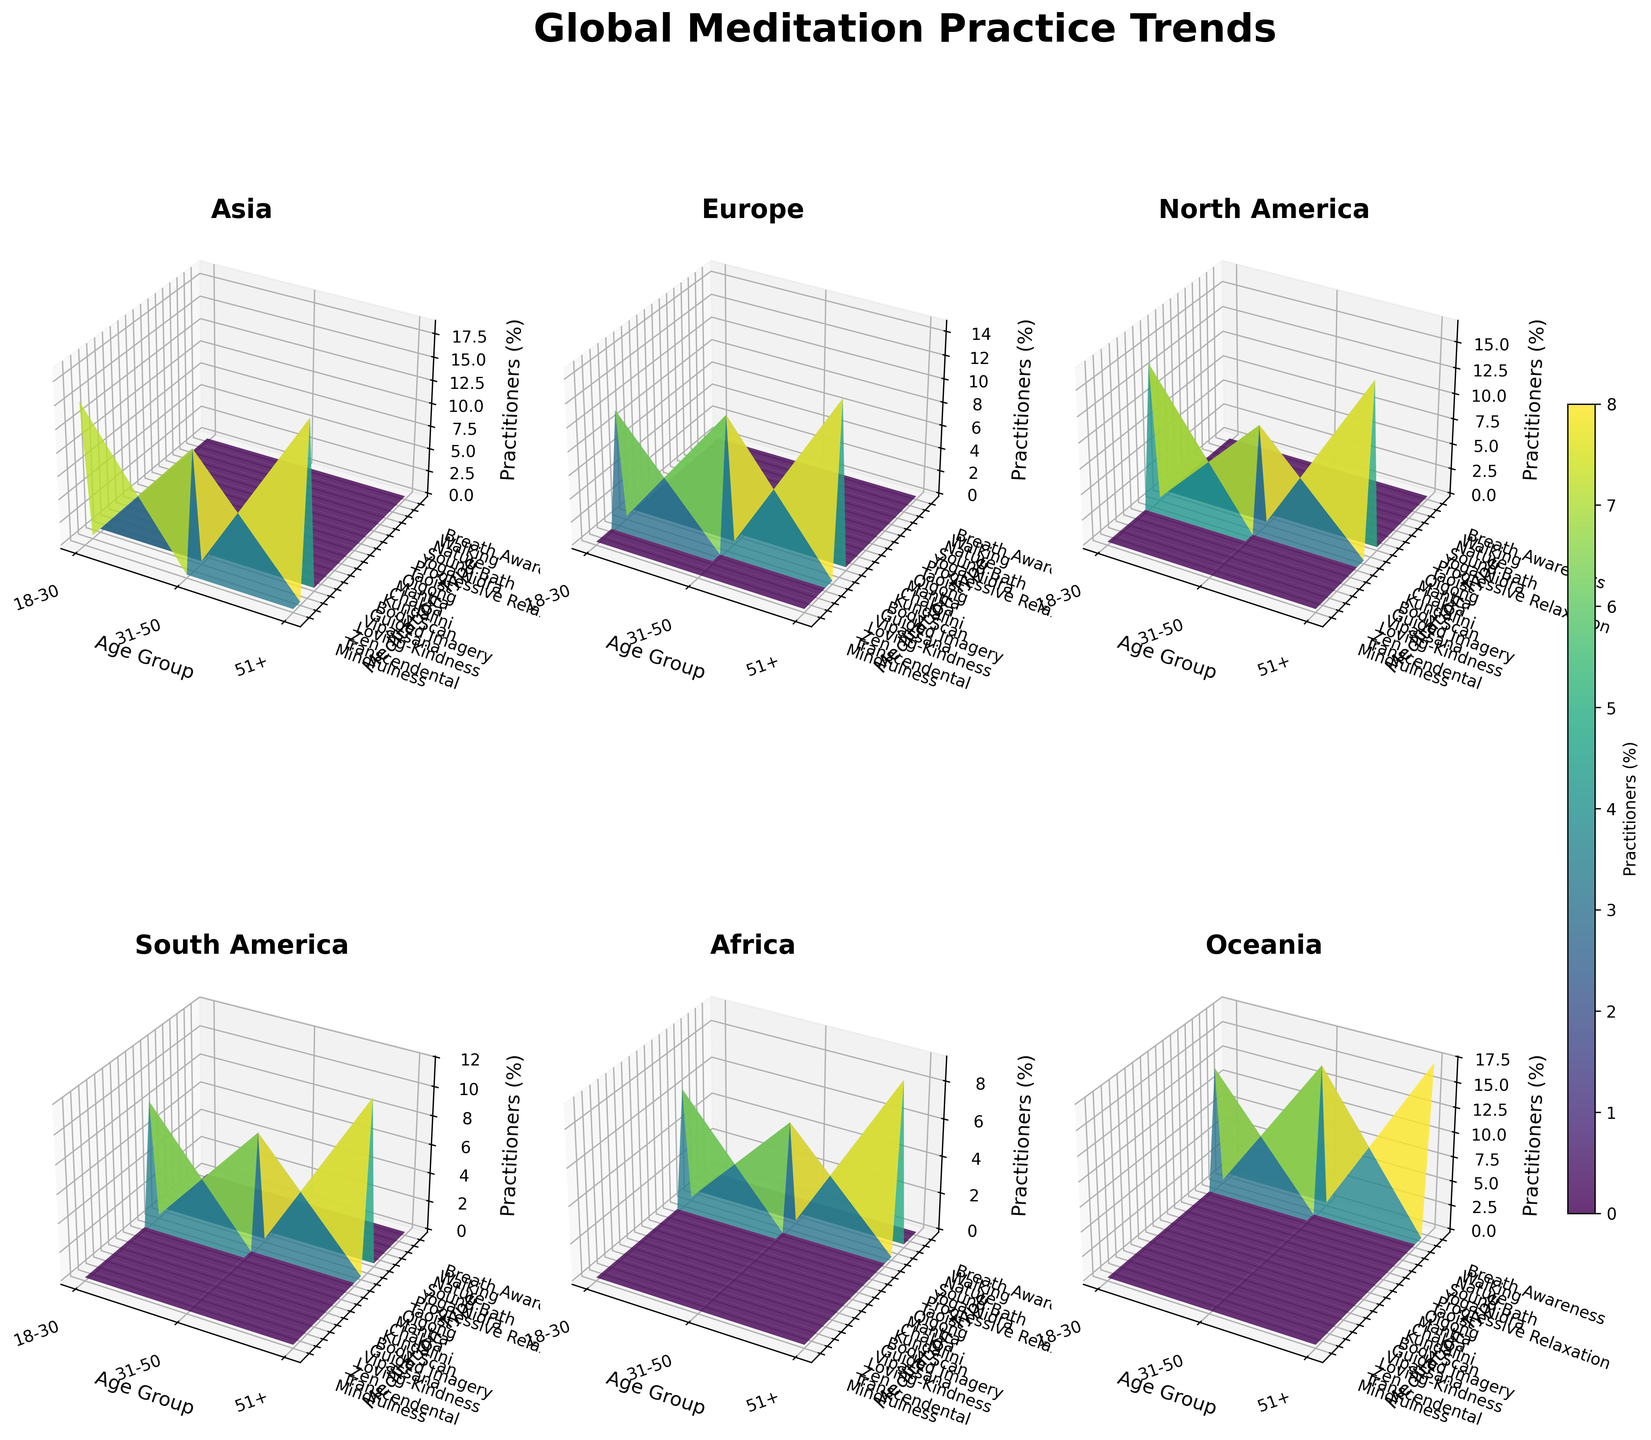Which continent has the highest percentage of meditation practitioners in older age groups (51+)? In the figure, compare the z-axis values (Practitioners Percentage) for different continents in the age group 51+. Observe that Asia has the highest z-value at 51+, which corresponds to 18.5% for Zen meditation.
Answer: Asia Which meditation type has the highest percentage of practitioners in North America for the 31-50 age group? Look at the subplot of North America and find the peak in the z-values on the corresponding "31-50 Age Group" x-axis value. The highest z-value here is 10.2% associated with Kundalini.
Answer: Kundalini Which age group in Europe has the lowest percentage of meditation practitioners and which practice is it? Check the subplot of Europe and find the smallest z-value across age groups. In the 18-30 age group, the lowest value is 9.7%, which corresponds to Loving-Kindness meditation.
Answer: 18-30, Loving-Kindness What is the percentage difference between Chakra meditation practitioners in North America and Sound Bath practitioners in Africa for the 51+ age group? In the North America subplot, the percentage for Chakra practitioners in the 51+ age group is 16.7%. In the Africa subplot, the percentage for Sound Bath practitioners in the same age group is 9.1%. The difference is 16.7% - 9.1% = 7.6%.
Answer: 7.6% Which continent has the most uniform distribution of meditation practitioners across different age groups? To determine uniformity, observe the z-values for each age group per continent. The subplot where the z-values are closely clustered indicates uniform distribution. Oceania has the most uniform values, hovering closely around 12-17%.
Answer: Oceania In Asia, how does the percentage of practitioners for Zen meditation in the 51+ age group compare to the percentage for Transcendental meditation in the 31-50 age group? In the Asia subplot, find the z-value associated with Zen meditation in the 51+ age group (18.5%) and compare it with the z-value for Transcendental meditation in the 31-50 age group (12.8%). Zen meditation has a higher percentage.
Answer: Zen meditation (51+): 18.5% > Transcendental meditation (31-50): 12.8% Which is the predominant meditation type in South America for individuals aged 18-30? In the South America subplot, look for the highest z-value under the 18-30 age group. The peak corresponds to the Mantra meditation type with 8.5%.
Answer: Mantra How does the percentage of Body Scan practitioners in North America for the 18-30 age group compare to Progressive Relaxation practitioners in Africa for the same age group? In the North America subplot, the percentage for Body Scan meditation (18-30) is 13.9%. In the Africa subplot, the percentage for Progressive Relaxation (18-30) is 6.3%. Body Scan has a higher percentage.
Answer: Body Scan: 13.9% > Progressive Relaxation: 6.3% What trend can be observed in Oceania regarding the percentage of meditation practitioners as age increases? Look at the Oceania subplot and observe the z-values from the 18-30 to 51+ age groups. Notice how the percentages increase from 12.4% (Nature in 18-30) to 14.8% (Walking in 31-50) and peak at 17.2% (Breath Awareness in 51+). This indicates an increasing trend with age.
Answer: Increasing trend Which continent has the least variation in z-values (percentage of practitioners) for different meditation types? By comparing the subplots for each continent, note the range of z-values (difference between maximum and minimum). Africa's subplot shows the least variation, indicating smaller differences in the percentages, ranging from 5.7% (Yoga Nidra) to 9.1% (Sound Bath).
Answer: Africa 